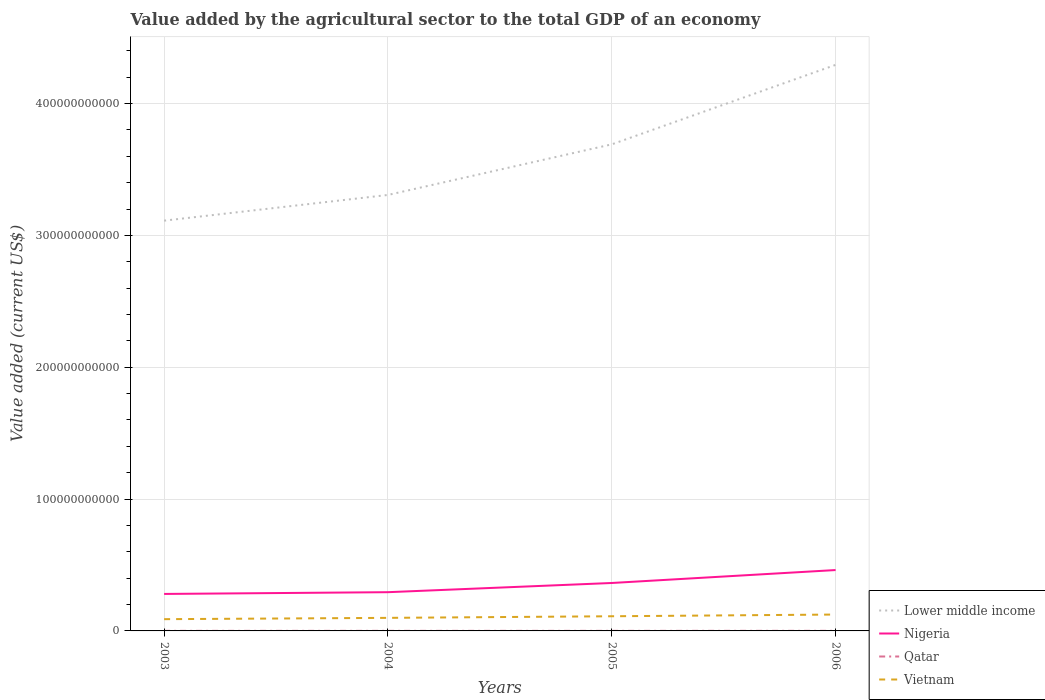Across all years, what is the maximum value added by the agricultural sector to the total GDP in Vietnam?
Your answer should be very brief. 8.92e+09. What is the total value added by the agricultural sector to the total GDP in Vietnam in the graph?
Make the answer very short. -9.91e+08. What is the difference between the highest and the second highest value added by the agricultural sector to the total GDP in Vietnam?
Offer a very short reply. 3.51e+09. What is the difference between the highest and the lowest value added by the agricultural sector to the total GDP in Vietnam?
Your answer should be compact. 2. How many lines are there?
Make the answer very short. 4. How many years are there in the graph?
Your response must be concise. 4. What is the difference between two consecutive major ticks on the Y-axis?
Give a very brief answer. 1.00e+11. Are the values on the major ticks of Y-axis written in scientific E-notation?
Make the answer very short. No. Does the graph contain any zero values?
Your response must be concise. No. Does the graph contain grids?
Keep it short and to the point. Yes. How many legend labels are there?
Your response must be concise. 4. What is the title of the graph?
Your answer should be very brief. Value added by the agricultural sector to the total GDP of an economy. What is the label or title of the Y-axis?
Give a very brief answer. Value added (current US$). What is the Value added (current US$) in Lower middle income in 2003?
Give a very brief answer. 3.11e+11. What is the Value added (current US$) in Nigeria in 2003?
Provide a short and direct response. 2.80e+1. What is the Value added (current US$) in Qatar in 2003?
Make the answer very short. 5.52e+07. What is the Value added (current US$) of Vietnam in 2003?
Your response must be concise. 8.92e+09. What is the Value added (current US$) of Lower middle income in 2004?
Ensure brevity in your answer.  3.31e+11. What is the Value added (current US$) of Nigeria in 2004?
Your response must be concise. 2.94e+1. What is the Value added (current US$) in Qatar in 2004?
Keep it short and to the point. 5.77e+07. What is the Value added (current US$) of Vietnam in 2004?
Provide a short and direct response. 9.91e+09. What is the Value added (current US$) of Lower middle income in 2005?
Ensure brevity in your answer.  3.69e+11. What is the Value added (current US$) of Nigeria in 2005?
Ensure brevity in your answer.  3.64e+1. What is the Value added (current US$) of Qatar in 2005?
Offer a terse response. 5.93e+07. What is the Value added (current US$) in Vietnam in 2005?
Give a very brief answer. 1.11e+1. What is the Value added (current US$) in Lower middle income in 2006?
Your answer should be very brief. 4.29e+11. What is the Value added (current US$) of Nigeria in 2006?
Your answer should be compact. 4.62e+1. What is the Value added (current US$) in Qatar in 2006?
Offer a very short reply. 7.42e+07. What is the Value added (current US$) of Vietnam in 2006?
Provide a short and direct response. 1.24e+1. Across all years, what is the maximum Value added (current US$) in Lower middle income?
Your response must be concise. 4.29e+11. Across all years, what is the maximum Value added (current US$) of Nigeria?
Your response must be concise. 4.62e+1. Across all years, what is the maximum Value added (current US$) of Qatar?
Your answer should be compact. 7.42e+07. Across all years, what is the maximum Value added (current US$) of Vietnam?
Your answer should be very brief. 1.24e+1. Across all years, what is the minimum Value added (current US$) in Lower middle income?
Your response must be concise. 3.11e+11. Across all years, what is the minimum Value added (current US$) of Nigeria?
Your answer should be very brief. 2.80e+1. Across all years, what is the minimum Value added (current US$) of Qatar?
Offer a terse response. 5.52e+07. Across all years, what is the minimum Value added (current US$) in Vietnam?
Offer a very short reply. 8.92e+09. What is the total Value added (current US$) of Lower middle income in the graph?
Your answer should be compact. 1.44e+12. What is the total Value added (current US$) of Nigeria in the graph?
Your answer should be compact. 1.40e+11. What is the total Value added (current US$) in Qatar in the graph?
Provide a short and direct response. 2.46e+08. What is the total Value added (current US$) of Vietnam in the graph?
Give a very brief answer. 4.24e+1. What is the difference between the Value added (current US$) of Lower middle income in 2003 and that in 2004?
Offer a very short reply. -1.95e+1. What is the difference between the Value added (current US$) of Nigeria in 2003 and that in 2004?
Ensure brevity in your answer.  -1.33e+09. What is the difference between the Value added (current US$) in Qatar in 2003 and that in 2004?
Make the answer very short. -2.47e+06. What is the difference between the Value added (current US$) in Vietnam in 2003 and that in 2004?
Your answer should be very brief. -9.91e+08. What is the difference between the Value added (current US$) in Lower middle income in 2003 and that in 2005?
Offer a terse response. -5.79e+1. What is the difference between the Value added (current US$) in Nigeria in 2003 and that in 2005?
Ensure brevity in your answer.  -8.31e+09. What is the difference between the Value added (current US$) in Qatar in 2003 and that in 2005?
Keep it short and to the point. -4.12e+06. What is the difference between the Value added (current US$) in Vietnam in 2003 and that in 2005?
Ensure brevity in your answer.  -2.21e+09. What is the difference between the Value added (current US$) in Lower middle income in 2003 and that in 2006?
Ensure brevity in your answer.  -1.18e+11. What is the difference between the Value added (current US$) in Nigeria in 2003 and that in 2006?
Provide a short and direct response. -1.81e+1. What is the difference between the Value added (current US$) of Qatar in 2003 and that in 2006?
Give a very brief answer. -1.90e+07. What is the difference between the Value added (current US$) in Vietnam in 2003 and that in 2006?
Offer a terse response. -3.51e+09. What is the difference between the Value added (current US$) of Lower middle income in 2004 and that in 2005?
Offer a terse response. -3.84e+1. What is the difference between the Value added (current US$) in Nigeria in 2004 and that in 2005?
Provide a short and direct response. -6.98e+09. What is the difference between the Value added (current US$) of Qatar in 2004 and that in 2005?
Offer a very short reply. -1.65e+06. What is the difference between the Value added (current US$) in Vietnam in 2004 and that in 2005?
Provide a short and direct response. -1.22e+09. What is the difference between the Value added (current US$) of Lower middle income in 2004 and that in 2006?
Your answer should be compact. -9.87e+1. What is the difference between the Value added (current US$) of Nigeria in 2004 and that in 2006?
Ensure brevity in your answer.  -1.68e+1. What is the difference between the Value added (current US$) in Qatar in 2004 and that in 2006?
Keep it short and to the point. -1.65e+07. What is the difference between the Value added (current US$) in Vietnam in 2004 and that in 2006?
Ensure brevity in your answer.  -2.52e+09. What is the difference between the Value added (current US$) of Lower middle income in 2005 and that in 2006?
Provide a succinct answer. -6.03e+1. What is the difference between the Value added (current US$) in Nigeria in 2005 and that in 2006?
Offer a terse response. -9.81e+09. What is the difference between the Value added (current US$) of Qatar in 2005 and that in 2006?
Provide a succinct answer. -1.48e+07. What is the difference between the Value added (current US$) in Vietnam in 2005 and that in 2006?
Provide a succinct answer. -1.31e+09. What is the difference between the Value added (current US$) in Lower middle income in 2003 and the Value added (current US$) in Nigeria in 2004?
Your answer should be compact. 2.82e+11. What is the difference between the Value added (current US$) of Lower middle income in 2003 and the Value added (current US$) of Qatar in 2004?
Keep it short and to the point. 3.11e+11. What is the difference between the Value added (current US$) in Lower middle income in 2003 and the Value added (current US$) in Vietnam in 2004?
Provide a short and direct response. 3.01e+11. What is the difference between the Value added (current US$) of Nigeria in 2003 and the Value added (current US$) of Qatar in 2004?
Offer a terse response. 2.80e+1. What is the difference between the Value added (current US$) of Nigeria in 2003 and the Value added (current US$) of Vietnam in 2004?
Your answer should be compact. 1.81e+1. What is the difference between the Value added (current US$) in Qatar in 2003 and the Value added (current US$) in Vietnam in 2004?
Offer a terse response. -9.85e+09. What is the difference between the Value added (current US$) of Lower middle income in 2003 and the Value added (current US$) of Nigeria in 2005?
Give a very brief answer. 2.75e+11. What is the difference between the Value added (current US$) in Lower middle income in 2003 and the Value added (current US$) in Qatar in 2005?
Provide a short and direct response. 3.11e+11. What is the difference between the Value added (current US$) in Lower middle income in 2003 and the Value added (current US$) in Vietnam in 2005?
Provide a short and direct response. 3.00e+11. What is the difference between the Value added (current US$) in Nigeria in 2003 and the Value added (current US$) in Qatar in 2005?
Offer a terse response. 2.80e+1. What is the difference between the Value added (current US$) in Nigeria in 2003 and the Value added (current US$) in Vietnam in 2005?
Offer a terse response. 1.69e+1. What is the difference between the Value added (current US$) of Qatar in 2003 and the Value added (current US$) of Vietnam in 2005?
Offer a terse response. -1.11e+1. What is the difference between the Value added (current US$) of Lower middle income in 2003 and the Value added (current US$) of Nigeria in 2006?
Provide a succinct answer. 2.65e+11. What is the difference between the Value added (current US$) of Lower middle income in 2003 and the Value added (current US$) of Qatar in 2006?
Make the answer very short. 3.11e+11. What is the difference between the Value added (current US$) of Lower middle income in 2003 and the Value added (current US$) of Vietnam in 2006?
Your response must be concise. 2.99e+11. What is the difference between the Value added (current US$) in Nigeria in 2003 and the Value added (current US$) in Qatar in 2006?
Ensure brevity in your answer.  2.80e+1. What is the difference between the Value added (current US$) of Nigeria in 2003 and the Value added (current US$) of Vietnam in 2006?
Your answer should be compact. 1.56e+1. What is the difference between the Value added (current US$) in Qatar in 2003 and the Value added (current US$) in Vietnam in 2006?
Make the answer very short. -1.24e+1. What is the difference between the Value added (current US$) in Lower middle income in 2004 and the Value added (current US$) in Nigeria in 2005?
Your answer should be very brief. 2.94e+11. What is the difference between the Value added (current US$) of Lower middle income in 2004 and the Value added (current US$) of Qatar in 2005?
Your response must be concise. 3.31e+11. What is the difference between the Value added (current US$) of Lower middle income in 2004 and the Value added (current US$) of Vietnam in 2005?
Your response must be concise. 3.20e+11. What is the difference between the Value added (current US$) in Nigeria in 2004 and the Value added (current US$) in Qatar in 2005?
Keep it short and to the point. 2.93e+1. What is the difference between the Value added (current US$) in Nigeria in 2004 and the Value added (current US$) in Vietnam in 2005?
Ensure brevity in your answer.  1.83e+1. What is the difference between the Value added (current US$) of Qatar in 2004 and the Value added (current US$) of Vietnam in 2005?
Your response must be concise. -1.11e+1. What is the difference between the Value added (current US$) of Lower middle income in 2004 and the Value added (current US$) of Nigeria in 2006?
Offer a very short reply. 2.84e+11. What is the difference between the Value added (current US$) of Lower middle income in 2004 and the Value added (current US$) of Qatar in 2006?
Provide a short and direct response. 3.31e+11. What is the difference between the Value added (current US$) in Lower middle income in 2004 and the Value added (current US$) in Vietnam in 2006?
Your answer should be compact. 3.18e+11. What is the difference between the Value added (current US$) in Nigeria in 2004 and the Value added (current US$) in Qatar in 2006?
Give a very brief answer. 2.93e+1. What is the difference between the Value added (current US$) of Nigeria in 2004 and the Value added (current US$) of Vietnam in 2006?
Keep it short and to the point. 1.69e+1. What is the difference between the Value added (current US$) in Qatar in 2004 and the Value added (current US$) in Vietnam in 2006?
Offer a terse response. -1.24e+1. What is the difference between the Value added (current US$) of Lower middle income in 2005 and the Value added (current US$) of Nigeria in 2006?
Make the answer very short. 3.23e+11. What is the difference between the Value added (current US$) of Lower middle income in 2005 and the Value added (current US$) of Qatar in 2006?
Provide a succinct answer. 3.69e+11. What is the difference between the Value added (current US$) of Lower middle income in 2005 and the Value added (current US$) of Vietnam in 2006?
Your answer should be very brief. 3.57e+11. What is the difference between the Value added (current US$) in Nigeria in 2005 and the Value added (current US$) in Qatar in 2006?
Your answer should be very brief. 3.63e+1. What is the difference between the Value added (current US$) in Nigeria in 2005 and the Value added (current US$) in Vietnam in 2006?
Offer a very short reply. 2.39e+1. What is the difference between the Value added (current US$) in Qatar in 2005 and the Value added (current US$) in Vietnam in 2006?
Ensure brevity in your answer.  -1.24e+1. What is the average Value added (current US$) of Lower middle income per year?
Keep it short and to the point. 3.60e+11. What is the average Value added (current US$) in Nigeria per year?
Your answer should be very brief. 3.50e+1. What is the average Value added (current US$) in Qatar per year?
Keep it short and to the point. 6.16e+07. What is the average Value added (current US$) in Vietnam per year?
Offer a terse response. 1.06e+1. In the year 2003, what is the difference between the Value added (current US$) in Lower middle income and Value added (current US$) in Nigeria?
Provide a succinct answer. 2.83e+11. In the year 2003, what is the difference between the Value added (current US$) of Lower middle income and Value added (current US$) of Qatar?
Offer a terse response. 3.11e+11. In the year 2003, what is the difference between the Value added (current US$) in Lower middle income and Value added (current US$) in Vietnam?
Your answer should be very brief. 3.02e+11. In the year 2003, what is the difference between the Value added (current US$) in Nigeria and Value added (current US$) in Qatar?
Give a very brief answer. 2.80e+1. In the year 2003, what is the difference between the Value added (current US$) in Nigeria and Value added (current US$) in Vietnam?
Offer a very short reply. 1.91e+1. In the year 2003, what is the difference between the Value added (current US$) of Qatar and Value added (current US$) of Vietnam?
Keep it short and to the point. -8.86e+09. In the year 2004, what is the difference between the Value added (current US$) of Lower middle income and Value added (current US$) of Nigeria?
Give a very brief answer. 3.01e+11. In the year 2004, what is the difference between the Value added (current US$) in Lower middle income and Value added (current US$) in Qatar?
Provide a succinct answer. 3.31e+11. In the year 2004, what is the difference between the Value added (current US$) in Lower middle income and Value added (current US$) in Vietnam?
Your answer should be very brief. 3.21e+11. In the year 2004, what is the difference between the Value added (current US$) in Nigeria and Value added (current US$) in Qatar?
Provide a succinct answer. 2.93e+1. In the year 2004, what is the difference between the Value added (current US$) of Nigeria and Value added (current US$) of Vietnam?
Provide a short and direct response. 1.95e+1. In the year 2004, what is the difference between the Value added (current US$) of Qatar and Value added (current US$) of Vietnam?
Your response must be concise. -9.85e+09. In the year 2005, what is the difference between the Value added (current US$) of Lower middle income and Value added (current US$) of Nigeria?
Ensure brevity in your answer.  3.33e+11. In the year 2005, what is the difference between the Value added (current US$) of Lower middle income and Value added (current US$) of Qatar?
Your answer should be compact. 3.69e+11. In the year 2005, what is the difference between the Value added (current US$) in Lower middle income and Value added (current US$) in Vietnam?
Give a very brief answer. 3.58e+11. In the year 2005, what is the difference between the Value added (current US$) in Nigeria and Value added (current US$) in Qatar?
Make the answer very short. 3.63e+1. In the year 2005, what is the difference between the Value added (current US$) in Nigeria and Value added (current US$) in Vietnam?
Your response must be concise. 2.52e+1. In the year 2005, what is the difference between the Value added (current US$) in Qatar and Value added (current US$) in Vietnam?
Your answer should be very brief. -1.11e+1. In the year 2006, what is the difference between the Value added (current US$) in Lower middle income and Value added (current US$) in Nigeria?
Provide a short and direct response. 3.83e+11. In the year 2006, what is the difference between the Value added (current US$) of Lower middle income and Value added (current US$) of Qatar?
Your answer should be compact. 4.29e+11. In the year 2006, what is the difference between the Value added (current US$) of Lower middle income and Value added (current US$) of Vietnam?
Offer a very short reply. 4.17e+11. In the year 2006, what is the difference between the Value added (current US$) of Nigeria and Value added (current US$) of Qatar?
Your response must be concise. 4.61e+1. In the year 2006, what is the difference between the Value added (current US$) in Nigeria and Value added (current US$) in Vietnam?
Your response must be concise. 3.37e+1. In the year 2006, what is the difference between the Value added (current US$) of Qatar and Value added (current US$) of Vietnam?
Provide a succinct answer. -1.24e+1. What is the ratio of the Value added (current US$) in Lower middle income in 2003 to that in 2004?
Your response must be concise. 0.94. What is the ratio of the Value added (current US$) of Nigeria in 2003 to that in 2004?
Your answer should be very brief. 0.95. What is the ratio of the Value added (current US$) of Qatar in 2003 to that in 2004?
Offer a terse response. 0.96. What is the ratio of the Value added (current US$) in Lower middle income in 2003 to that in 2005?
Provide a short and direct response. 0.84. What is the ratio of the Value added (current US$) in Nigeria in 2003 to that in 2005?
Offer a very short reply. 0.77. What is the ratio of the Value added (current US$) of Qatar in 2003 to that in 2005?
Make the answer very short. 0.93. What is the ratio of the Value added (current US$) in Vietnam in 2003 to that in 2005?
Your answer should be compact. 0.8. What is the ratio of the Value added (current US$) of Lower middle income in 2003 to that in 2006?
Provide a short and direct response. 0.72. What is the ratio of the Value added (current US$) of Nigeria in 2003 to that in 2006?
Your answer should be very brief. 0.61. What is the ratio of the Value added (current US$) in Qatar in 2003 to that in 2006?
Your answer should be compact. 0.74. What is the ratio of the Value added (current US$) of Vietnam in 2003 to that in 2006?
Ensure brevity in your answer.  0.72. What is the ratio of the Value added (current US$) in Lower middle income in 2004 to that in 2005?
Give a very brief answer. 0.9. What is the ratio of the Value added (current US$) in Nigeria in 2004 to that in 2005?
Provide a short and direct response. 0.81. What is the ratio of the Value added (current US$) of Qatar in 2004 to that in 2005?
Give a very brief answer. 0.97. What is the ratio of the Value added (current US$) in Vietnam in 2004 to that in 2005?
Make the answer very short. 0.89. What is the ratio of the Value added (current US$) in Lower middle income in 2004 to that in 2006?
Your response must be concise. 0.77. What is the ratio of the Value added (current US$) in Nigeria in 2004 to that in 2006?
Your answer should be very brief. 0.64. What is the ratio of the Value added (current US$) of Vietnam in 2004 to that in 2006?
Offer a terse response. 0.8. What is the ratio of the Value added (current US$) of Lower middle income in 2005 to that in 2006?
Your answer should be very brief. 0.86. What is the ratio of the Value added (current US$) in Nigeria in 2005 to that in 2006?
Make the answer very short. 0.79. What is the ratio of the Value added (current US$) of Vietnam in 2005 to that in 2006?
Keep it short and to the point. 0.89. What is the difference between the highest and the second highest Value added (current US$) of Lower middle income?
Your answer should be very brief. 6.03e+1. What is the difference between the highest and the second highest Value added (current US$) in Nigeria?
Offer a very short reply. 9.81e+09. What is the difference between the highest and the second highest Value added (current US$) in Qatar?
Give a very brief answer. 1.48e+07. What is the difference between the highest and the second highest Value added (current US$) in Vietnam?
Provide a short and direct response. 1.31e+09. What is the difference between the highest and the lowest Value added (current US$) of Lower middle income?
Your answer should be very brief. 1.18e+11. What is the difference between the highest and the lowest Value added (current US$) of Nigeria?
Make the answer very short. 1.81e+1. What is the difference between the highest and the lowest Value added (current US$) of Qatar?
Offer a terse response. 1.90e+07. What is the difference between the highest and the lowest Value added (current US$) of Vietnam?
Give a very brief answer. 3.51e+09. 